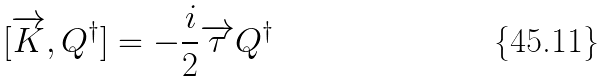<formula> <loc_0><loc_0><loc_500><loc_500>[ \overrightarrow { K } , Q ^ { \dagger } ] = - \frac { i } { 2 } \overrightarrow { \tau } Q ^ { \dagger }</formula> 